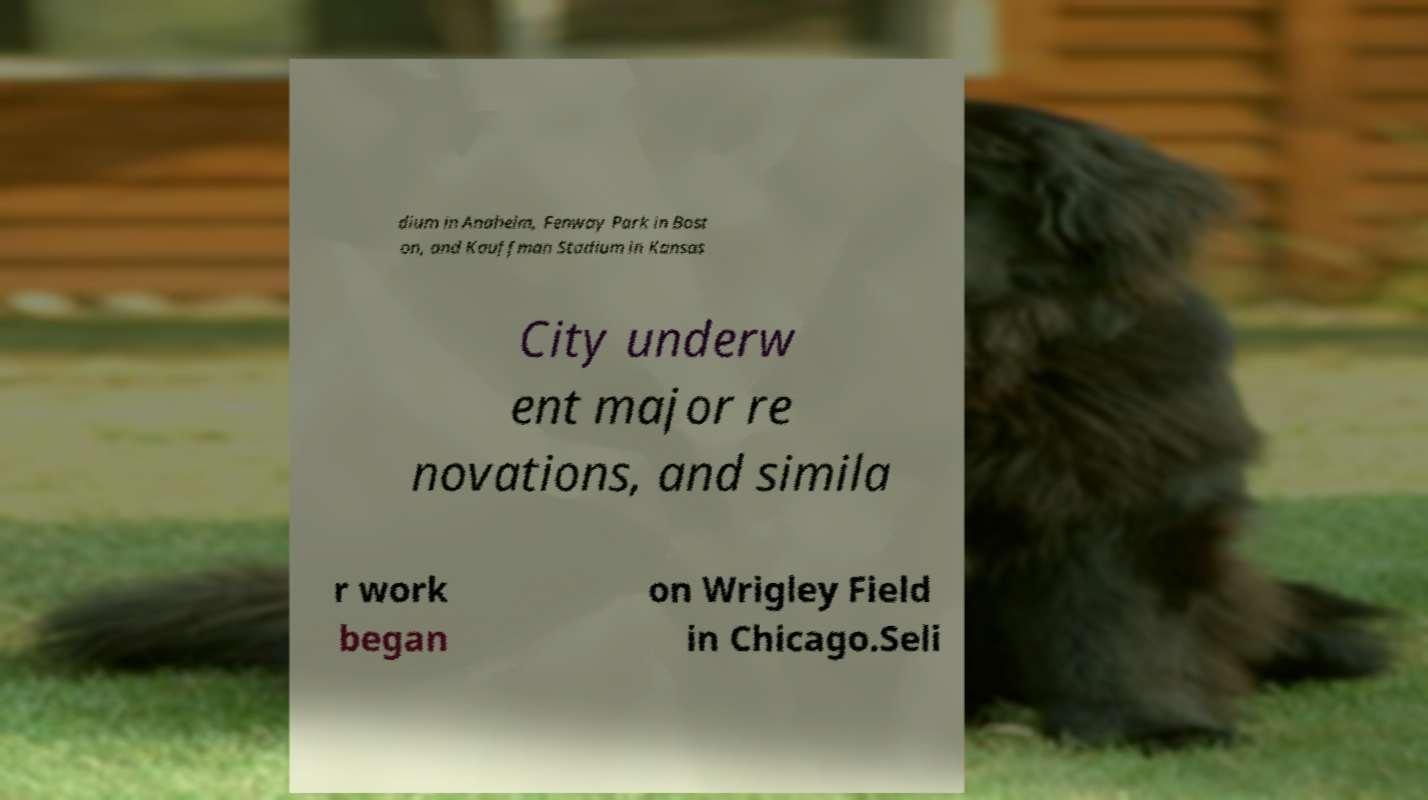Could you extract and type out the text from this image? dium in Anaheim, Fenway Park in Bost on, and Kauffman Stadium in Kansas City underw ent major re novations, and simila r work began on Wrigley Field in Chicago.Seli 